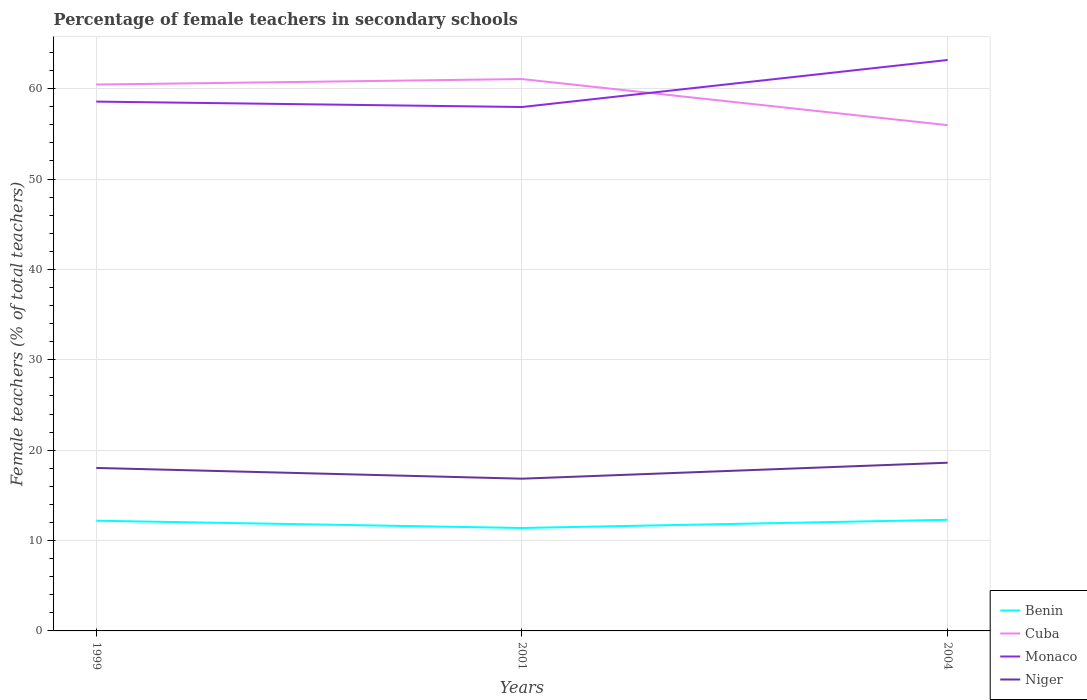How many different coloured lines are there?
Offer a terse response. 4. Across all years, what is the maximum percentage of female teachers in Benin?
Make the answer very short. 11.39. In which year was the percentage of female teachers in Monaco maximum?
Offer a very short reply. 2001. What is the total percentage of female teachers in Niger in the graph?
Make the answer very short. -0.58. What is the difference between the highest and the second highest percentage of female teachers in Cuba?
Provide a short and direct response. 5.1. Is the percentage of female teachers in Benin strictly greater than the percentage of female teachers in Cuba over the years?
Make the answer very short. Yes. How many lines are there?
Give a very brief answer. 4. How many years are there in the graph?
Provide a succinct answer. 3. What is the difference between two consecutive major ticks on the Y-axis?
Your answer should be compact. 10. Are the values on the major ticks of Y-axis written in scientific E-notation?
Keep it short and to the point. No. Does the graph contain grids?
Offer a very short reply. Yes. Where does the legend appear in the graph?
Keep it short and to the point. Bottom right. How many legend labels are there?
Your response must be concise. 4. What is the title of the graph?
Provide a succinct answer. Percentage of female teachers in secondary schools. What is the label or title of the X-axis?
Provide a short and direct response. Years. What is the label or title of the Y-axis?
Offer a terse response. Female teachers (% of total teachers). What is the Female teachers (% of total teachers) of Benin in 1999?
Your answer should be very brief. 12.19. What is the Female teachers (% of total teachers) of Cuba in 1999?
Offer a terse response. 60.46. What is the Female teachers (% of total teachers) in Monaco in 1999?
Ensure brevity in your answer.  58.57. What is the Female teachers (% of total teachers) in Niger in 1999?
Your answer should be very brief. 18.03. What is the Female teachers (% of total teachers) of Benin in 2001?
Your answer should be compact. 11.39. What is the Female teachers (% of total teachers) of Cuba in 2001?
Ensure brevity in your answer.  61.06. What is the Female teachers (% of total teachers) in Monaco in 2001?
Give a very brief answer. 57.97. What is the Female teachers (% of total teachers) of Niger in 2001?
Your response must be concise. 16.84. What is the Female teachers (% of total teachers) in Benin in 2004?
Your answer should be very brief. 12.3. What is the Female teachers (% of total teachers) in Cuba in 2004?
Ensure brevity in your answer.  55.97. What is the Female teachers (% of total teachers) of Monaco in 2004?
Provide a short and direct response. 63.18. What is the Female teachers (% of total teachers) in Niger in 2004?
Your answer should be very brief. 18.61. Across all years, what is the maximum Female teachers (% of total teachers) in Benin?
Give a very brief answer. 12.3. Across all years, what is the maximum Female teachers (% of total teachers) of Cuba?
Keep it short and to the point. 61.06. Across all years, what is the maximum Female teachers (% of total teachers) of Monaco?
Ensure brevity in your answer.  63.18. Across all years, what is the maximum Female teachers (% of total teachers) of Niger?
Offer a terse response. 18.61. Across all years, what is the minimum Female teachers (% of total teachers) of Benin?
Ensure brevity in your answer.  11.39. Across all years, what is the minimum Female teachers (% of total teachers) of Cuba?
Keep it short and to the point. 55.97. Across all years, what is the minimum Female teachers (% of total teachers) of Monaco?
Offer a very short reply. 57.97. Across all years, what is the minimum Female teachers (% of total teachers) of Niger?
Provide a short and direct response. 16.84. What is the total Female teachers (% of total teachers) in Benin in the graph?
Your answer should be very brief. 35.88. What is the total Female teachers (% of total teachers) in Cuba in the graph?
Offer a very short reply. 177.49. What is the total Female teachers (% of total teachers) of Monaco in the graph?
Keep it short and to the point. 179.72. What is the total Female teachers (% of total teachers) of Niger in the graph?
Provide a short and direct response. 53.49. What is the difference between the Female teachers (% of total teachers) of Benin in 1999 and that in 2001?
Your answer should be very brief. 0.8. What is the difference between the Female teachers (% of total teachers) in Cuba in 1999 and that in 2001?
Offer a terse response. -0.61. What is the difference between the Female teachers (% of total teachers) of Monaco in 1999 and that in 2001?
Keep it short and to the point. 0.6. What is the difference between the Female teachers (% of total teachers) in Niger in 1999 and that in 2001?
Provide a succinct answer. 1.19. What is the difference between the Female teachers (% of total teachers) of Benin in 1999 and that in 2004?
Make the answer very short. -0.1. What is the difference between the Female teachers (% of total teachers) in Cuba in 1999 and that in 2004?
Provide a succinct answer. 4.49. What is the difference between the Female teachers (% of total teachers) in Monaco in 1999 and that in 2004?
Provide a succinct answer. -4.61. What is the difference between the Female teachers (% of total teachers) of Niger in 1999 and that in 2004?
Provide a succinct answer. -0.58. What is the difference between the Female teachers (% of total teachers) of Benin in 2001 and that in 2004?
Provide a succinct answer. -0.91. What is the difference between the Female teachers (% of total teachers) in Cuba in 2001 and that in 2004?
Offer a very short reply. 5.1. What is the difference between the Female teachers (% of total teachers) of Monaco in 2001 and that in 2004?
Offer a terse response. -5.21. What is the difference between the Female teachers (% of total teachers) of Niger in 2001 and that in 2004?
Your answer should be very brief. -1.77. What is the difference between the Female teachers (% of total teachers) of Benin in 1999 and the Female teachers (% of total teachers) of Cuba in 2001?
Keep it short and to the point. -48.87. What is the difference between the Female teachers (% of total teachers) of Benin in 1999 and the Female teachers (% of total teachers) of Monaco in 2001?
Your answer should be very brief. -45.78. What is the difference between the Female teachers (% of total teachers) in Benin in 1999 and the Female teachers (% of total teachers) in Niger in 2001?
Your response must be concise. -4.65. What is the difference between the Female teachers (% of total teachers) in Cuba in 1999 and the Female teachers (% of total teachers) in Monaco in 2001?
Offer a terse response. 2.49. What is the difference between the Female teachers (% of total teachers) of Cuba in 1999 and the Female teachers (% of total teachers) of Niger in 2001?
Offer a very short reply. 43.61. What is the difference between the Female teachers (% of total teachers) in Monaco in 1999 and the Female teachers (% of total teachers) in Niger in 2001?
Offer a very short reply. 41.73. What is the difference between the Female teachers (% of total teachers) of Benin in 1999 and the Female teachers (% of total teachers) of Cuba in 2004?
Make the answer very short. -43.77. What is the difference between the Female teachers (% of total teachers) of Benin in 1999 and the Female teachers (% of total teachers) of Monaco in 2004?
Provide a short and direct response. -50.98. What is the difference between the Female teachers (% of total teachers) of Benin in 1999 and the Female teachers (% of total teachers) of Niger in 2004?
Provide a short and direct response. -6.42. What is the difference between the Female teachers (% of total teachers) of Cuba in 1999 and the Female teachers (% of total teachers) of Monaco in 2004?
Provide a succinct answer. -2.72. What is the difference between the Female teachers (% of total teachers) of Cuba in 1999 and the Female teachers (% of total teachers) of Niger in 2004?
Provide a short and direct response. 41.85. What is the difference between the Female teachers (% of total teachers) in Monaco in 1999 and the Female teachers (% of total teachers) in Niger in 2004?
Your answer should be compact. 39.96. What is the difference between the Female teachers (% of total teachers) in Benin in 2001 and the Female teachers (% of total teachers) in Cuba in 2004?
Offer a terse response. -44.57. What is the difference between the Female teachers (% of total teachers) of Benin in 2001 and the Female teachers (% of total teachers) of Monaco in 2004?
Offer a terse response. -51.79. What is the difference between the Female teachers (% of total teachers) in Benin in 2001 and the Female teachers (% of total teachers) in Niger in 2004?
Your response must be concise. -7.22. What is the difference between the Female teachers (% of total teachers) in Cuba in 2001 and the Female teachers (% of total teachers) in Monaco in 2004?
Give a very brief answer. -2.11. What is the difference between the Female teachers (% of total teachers) in Cuba in 2001 and the Female teachers (% of total teachers) in Niger in 2004?
Give a very brief answer. 42.45. What is the difference between the Female teachers (% of total teachers) of Monaco in 2001 and the Female teachers (% of total teachers) of Niger in 2004?
Your answer should be compact. 39.36. What is the average Female teachers (% of total teachers) of Benin per year?
Offer a very short reply. 11.96. What is the average Female teachers (% of total teachers) in Cuba per year?
Provide a short and direct response. 59.16. What is the average Female teachers (% of total teachers) in Monaco per year?
Give a very brief answer. 59.91. What is the average Female teachers (% of total teachers) in Niger per year?
Offer a terse response. 17.83. In the year 1999, what is the difference between the Female teachers (% of total teachers) in Benin and Female teachers (% of total teachers) in Cuba?
Offer a very short reply. -48.26. In the year 1999, what is the difference between the Female teachers (% of total teachers) in Benin and Female teachers (% of total teachers) in Monaco?
Provide a short and direct response. -46.38. In the year 1999, what is the difference between the Female teachers (% of total teachers) in Benin and Female teachers (% of total teachers) in Niger?
Give a very brief answer. -5.84. In the year 1999, what is the difference between the Female teachers (% of total teachers) of Cuba and Female teachers (% of total teachers) of Monaco?
Your response must be concise. 1.89. In the year 1999, what is the difference between the Female teachers (% of total teachers) of Cuba and Female teachers (% of total teachers) of Niger?
Your response must be concise. 42.42. In the year 1999, what is the difference between the Female teachers (% of total teachers) of Monaco and Female teachers (% of total teachers) of Niger?
Make the answer very short. 40.54. In the year 2001, what is the difference between the Female teachers (% of total teachers) of Benin and Female teachers (% of total teachers) of Cuba?
Make the answer very short. -49.67. In the year 2001, what is the difference between the Female teachers (% of total teachers) of Benin and Female teachers (% of total teachers) of Monaco?
Offer a terse response. -46.58. In the year 2001, what is the difference between the Female teachers (% of total teachers) of Benin and Female teachers (% of total teachers) of Niger?
Your answer should be very brief. -5.45. In the year 2001, what is the difference between the Female teachers (% of total teachers) in Cuba and Female teachers (% of total teachers) in Monaco?
Provide a short and direct response. 3.09. In the year 2001, what is the difference between the Female teachers (% of total teachers) of Cuba and Female teachers (% of total teachers) of Niger?
Your response must be concise. 44.22. In the year 2001, what is the difference between the Female teachers (% of total teachers) of Monaco and Female teachers (% of total teachers) of Niger?
Make the answer very short. 41.13. In the year 2004, what is the difference between the Female teachers (% of total teachers) in Benin and Female teachers (% of total teachers) in Cuba?
Offer a very short reply. -43.67. In the year 2004, what is the difference between the Female teachers (% of total teachers) of Benin and Female teachers (% of total teachers) of Monaco?
Your answer should be very brief. -50.88. In the year 2004, what is the difference between the Female teachers (% of total teachers) of Benin and Female teachers (% of total teachers) of Niger?
Give a very brief answer. -6.32. In the year 2004, what is the difference between the Female teachers (% of total teachers) of Cuba and Female teachers (% of total teachers) of Monaco?
Ensure brevity in your answer.  -7.21. In the year 2004, what is the difference between the Female teachers (% of total teachers) of Cuba and Female teachers (% of total teachers) of Niger?
Provide a short and direct response. 37.35. In the year 2004, what is the difference between the Female teachers (% of total teachers) in Monaco and Female teachers (% of total teachers) in Niger?
Offer a very short reply. 44.56. What is the ratio of the Female teachers (% of total teachers) in Benin in 1999 to that in 2001?
Ensure brevity in your answer.  1.07. What is the ratio of the Female teachers (% of total teachers) in Cuba in 1999 to that in 2001?
Ensure brevity in your answer.  0.99. What is the ratio of the Female teachers (% of total teachers) in Monaco in 1999 to that in 2001?
Offer a terse response. 1.01. What is the ratio of the Female teachers (% of total teachers) in Niger in 1999 to that in 2001?
Make the answer very short. 1.07. What is the ratio of the Female teachers (% of total teachers) of Benin in 1999 to that in 2004?
Give a very brief answer. 0.99. What is the ratio of the Female teachers (% of total teachers) in Cuba in 1999 to that in 2004?
Offer a terse response. 1.08. What is the ratio of the Female teachers (% of total teachers) in Monaco in 1999 to that in 2004?
Keep it short and to the point. 0.93. What is the ratio of the Female teachers (% of total teachers) of Niger in 1999 to that in 2004?
Make the answer very short. 0.97. What is the ratio of the Female teachers (% of total teachers) of Benin in 2001 to that in 2004?
Your answer should be compact. 0.93. What is the ratio of the Female teachers (% of total teachers) of Cuba in 2001 to that in 2004?
Make the answer very short. 1.09. What is the ratio of the Female teachers (% of total teachers) in Monaco in 2001 to that in 2004?
Your answer should be very brief. 0.92. What is the ratio of the Female teachers (% of total teachers) in Niger in 2001 to that in 2004?
Your answer should be very brief. 0.91. What is the difference between the highest and the second highest Female teachers (% of total teachers) of Benin?
Your answer should be compact. 0.1. What is the difference between the highest and the second highest Female teachers (% of total teachers) of Cuba?
Your answer should be very brief. 0.61. What is the difference between the highest and the second highest Female teachers (% of total teachers) in Monaco?
Your answer should be compact. 4.61. What is the difference between the highest and the second highest Female teachers (% of total teachers) in Niger?
Keep it short and to the point. 0.58. What is the difference between the highest and the lowest Female teachers (% of total teachers) in Benin?
Offer a very short reply. 0.91. What is the difference between the highest and the lowest Female teachers (% of total teachers) in Cuba?
Ensure brevity in your answer.  5.1. What is the difference between the highest and the lowest Female teachers (% of total teachers) in Monaco?
Provide a succinct answer. 5.21. What is the difference between the highest and the lowest Female teachers (% of total teachers) in Niger?
Ensure brevity in your answer.  1.77. 